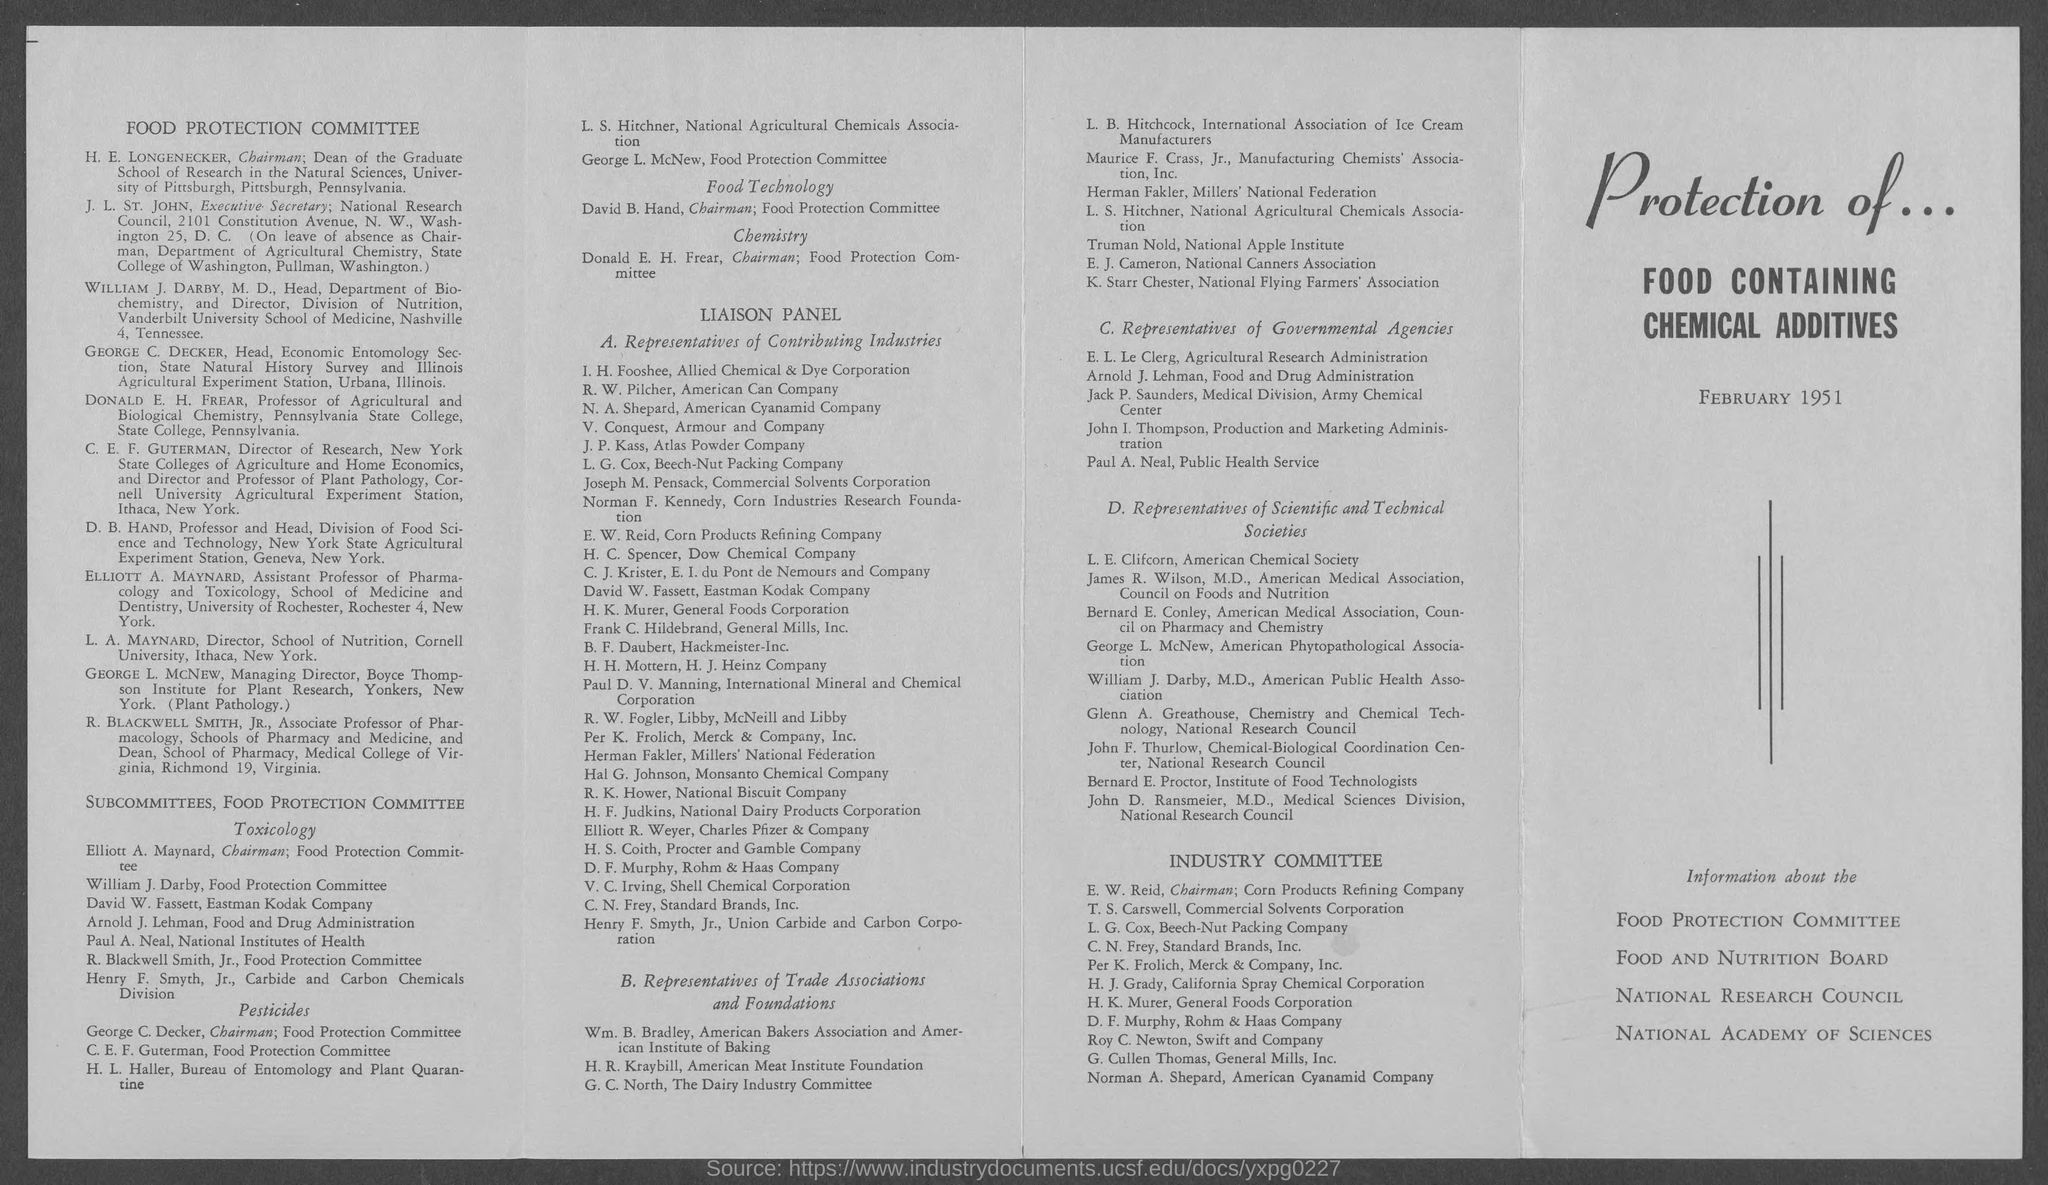Give some essential details in this illustration. David B. Hand is the chairman. 